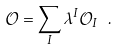<formula> <loc_0><loc_0><loc_500><loc_500>\mathcal { O } = \sum _ { I } \lambda ^ { I } \mathcal { O } _ { I } \ .</formula> 